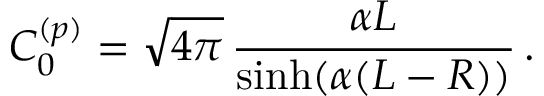Convert formula to latex. <formula><loc_0><loc_0><loc_500><loc_500>C _ { 0 } ^ { ( p ) } = \sqrt { 4 \pi } \, \frac { \alpha L } { \sinh ( \alpha ( L - R ) ) } \, .</formula> 